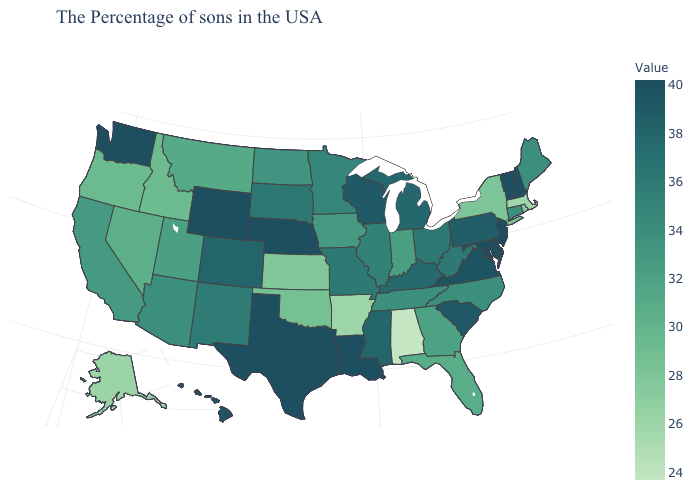Does New Mexico have a lower value than Colorado?
Keep it brief. Yes. Does Arkansas have a higher value than Alabama?
Give a very brief answer. Yes. Among the states that border Tennessee , does Alabama have the lowest value?
Concise answer only. Yes. Among the states that border Maine , which have the highest value?
Be succinct. New Hampshire. Which states have the highest value in the USA?
Short answer required. New Hampshire, Vermont, New Jersey, Delaware, Maryland, Louisiana, Nebraska, Texas, Wyoming, Washington. Among the states that border New Jersey , does New York have the highest value?
Give a very brief answer. No. Does Vermont have the highest value in the Northeast?
Give a very brief answer. Yes. Does Kentucky have a lower value than Utah?
Write a very short answer. No. Is the legend a continuous bar?
Short answer required. Yes. Which states have the lowest value in the Northeast?
Short answer required. Massachusetts. 